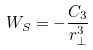Convert formula to latex. <formula><loc_0><loc_0><loc_500><loc_500>W _ { S } = - \frac { C _ { 3 } } { r _ { \perp } ^ { 3 } }</formula> 